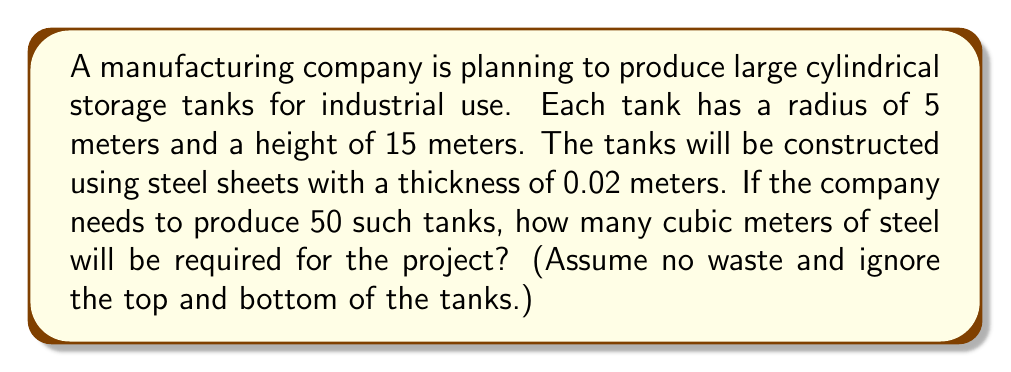Help me with this question. To solve this problem, we need to follow these steps:

1. Calculate the lateral surface area of one cylindrical tank.
2. Determine the volume of steel needed for one tank.
3. Multiply the result by the number of tanks to get the total volume of steel required.

Step 1: Lateral surface area of one tank
The formula for the lateral surface area of a cylinder is:
$$A = 2\pi rh$$
Where $r$ is the radius and $h$ is the height.

Substituting the values:
$$A = 2\pi \cdot 5 \cdot 15 = 150\pi \text{ m}^2$$

Step 2: Volume of steel for one tank
To find the volume, we multiply the surface area by the thickness of the steel:
$$V = A \cdot t$$
Where $t$ is the thickness.

$$V = 150\pi \cdot 0.02 = 3\pi \text{ m}^3$$

Step 3: Total volume for 50 tanks
Multiply the volume for one tank by 50:
$$V_{total} = 3\pi \cdot 50 = 150\pi \text{ m}^3$$

Converting to a decimal approximation:
$$V_{total} \approx 471.24 \text{ m}^3$$
Answer: The total volume of steel required for 50 tanks is approximately 471.24 cubic meters. 